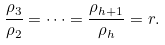<formula> <loc_0><loc_0><loc_500><loc_500>\frac { \rho _ { 3 } } { \rho _ { 2 } } = \cdots = \frac { \rho _ { h + 1 } } { \rho _ { h } } = r .</formula> 